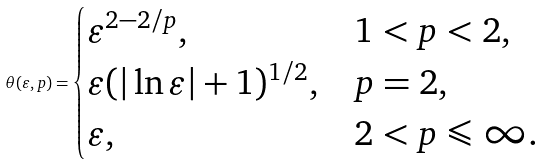Convert formula to latex. <formula><loc_0><loc_0><loc_500><loc_500>\theta ( \varepsilon , p ) = \begin{cases} \varepsilon ^ { 2 - 2 / p } , & 1 < p < 2 , \\ \varepsilon ( | \ln \varepsilon | + 1 ) ^ { 1 / 2 } , & p = 2 , \\ \varepsilon , & 2 < p \leqslant \infty . \end{cases}</formula> 